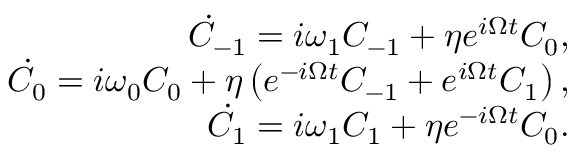Convert formula to latex. <formula><loc_0><loc_0><loc_500><loc_500>\begin{array} { r l r } & { \dot { C } _ { - 1 } = i \omega _ { 1 } C _ { - 1 } + \eta e ^ { i \Omega t } C _ { 0 } , } \\ & { \dot { C } _ { 0 } = i \omega _ { 0 } C _ { 0 } + \eta \left ( e ^ { - i \Omega t } C _ { - 1 } + e ^ { i \Omega t } C _ { 1 } \right ) , } \\ & { \dot { C } _ { 1 } = i \omega _ { 1 } C _ { 1 } + \eta e ^ { - i \Omega t } C _ { 0 } . } \end{array}</formula> 